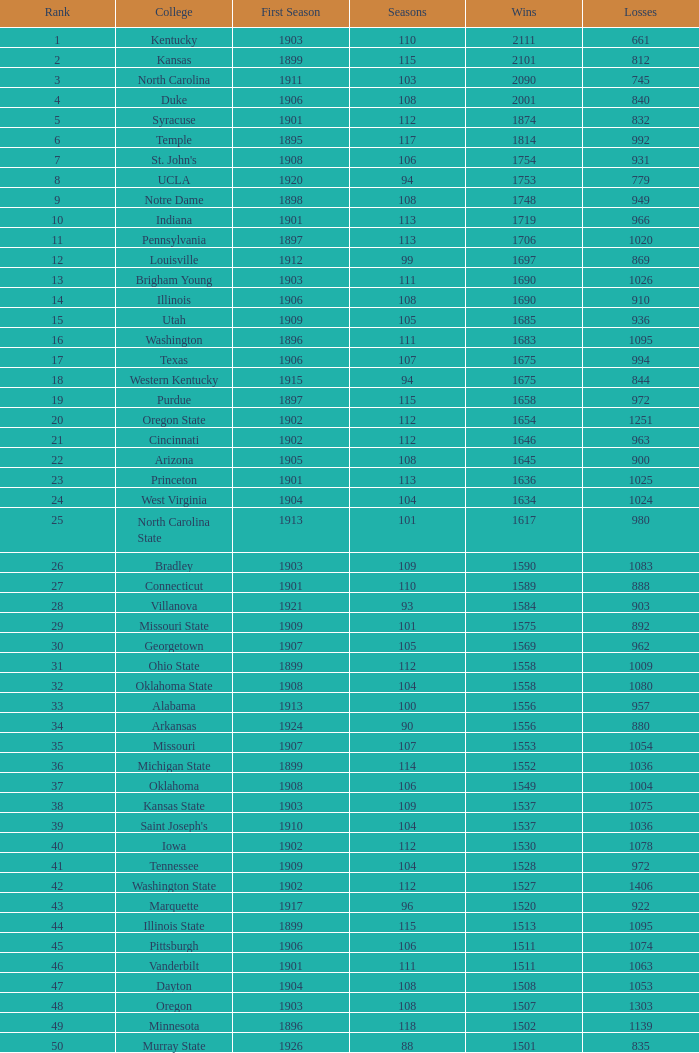What is the overall total of first season contests with 1537 triumphs and a season larger than 109? None. I'm looking to parse the entire table for insights. Could you assist me with that? {'header': ['Rank', 'College', 'First Season', 'Seasons', 'Wins', 'Losses'], 'rows': [['1', 'Kentucky', '1903', '110', '2111', '661'], ['2', 'Kansas', '1899', '115', '2101', '812'], ['3', 'North Carolina', '1911', '103', '2090', '745'], ['4', 'Duke', '1906', '108', '2001', '840'], ['5', 'Syracuse', '1901', '112', '1874', '832'], ['6', 'Temple', '1895', '117', '1814', '992'], ['7', "St. John's", '1908', '106', '1754', '931'], ['8', 'UCLA', '1920', '94', '1753', '779'], ['9', 'Notre Dame', '1898', '108', '1748', '949'], ['10', 'Indiana', '1901', '113', '1719', '966'], ['11', 'Pennsylvania', '1897', '113', '1706', '1020'], ['12', 'Louisville', '1912', '99', '1697', '869'], ['13', 'Brigham Young', '1903', '111', '1690', '1026'], ['14', 'Illinois', '1906', '108', '1690', '910'], ['15', 'Utah', '1909', '105', '1685', '936'], ['16', 'Washington', '1896', '111', '1683', '1095'], ['17', 'Texas', '1906', '107', '1675', '994'], ['18', 'Western Kentucky', '1915', '94', '1675', '844'], ['19', 'Purdue', '1897', '115', '1658', '972'], ['20', 'Oregon State', '1902', '112', '1654', '1251'], ['21', 'Cincinnati', '1902', '112', '1646', '963'], ['22', 'Arizona', '1905', '108', '1645', '900'], ['23', 'Princeton', '1901', '113', '1636', '1025'], ['24', 'West Virginia', '1904', '104', '1634', '1024'], ['25', 'North Carolina State', '1913', '101', '1617', '980'], ['26', 'Bradley', '1903', '109', '1590', '1083'], ['27', 'Connecticut', '1901', '110', '1589', '888'], ['28', 'Villanova', '1921', '93', '1584', '903'], ['29', 'Missouri State', '1909', '101', '1575', '892'], ['30', 'Georgetown', '1907', '105', '1569', '962'], ['31', 'Ohio State', '1899', '112', '1558', '1009'], ['32', 'Oklahoma State', '1908', '104', '1558', '1080'], ['33', 'Alabama', '1913', '100', '1556', '957'], ['34', 'Arkansas', '1924', '90', '1556', '880'], ['35', 'Missouri', '1907', '107', '1553', '1054'], ['36', 'Michigan State', '1899', '114', '1552', '1036'], ['37', 'Oklahoma', '1908', '106', '1549', '1004'], ['38', 'Kansas State', '1903', '109', '1537', '1075'], ['39', "Saint Joseph's", '1910', '104', '1537', '1036'], ['40', 'Iowa', '1902', '112', '1530', '1078'], ['41', 'Tennessee', '1909', '104', '1528', '972'], ['42', 'Washington State', '1902', '112', '1527', '1406'], ['43', 'Marquette', '1917', '96', '1520', '922'], ['44', 'Illinois State', '1899', '115', '1513', '1095'], ['45', 'Pittsburgh', '1906', '106', '1511', '1074'], ['46', 'Vanderbilt', '1901', '111', '1511', '1063'], ['47', 'Dayton', '1904', '108', '1508', '1053'], ['48', 'Oregon', '1903', '108', '1507', '1303'], ['49', 'Minnesota', '1896', '118', '1502', '1139'], ['50', 'Murray State', '1926', '88', '1501', '835']]} 